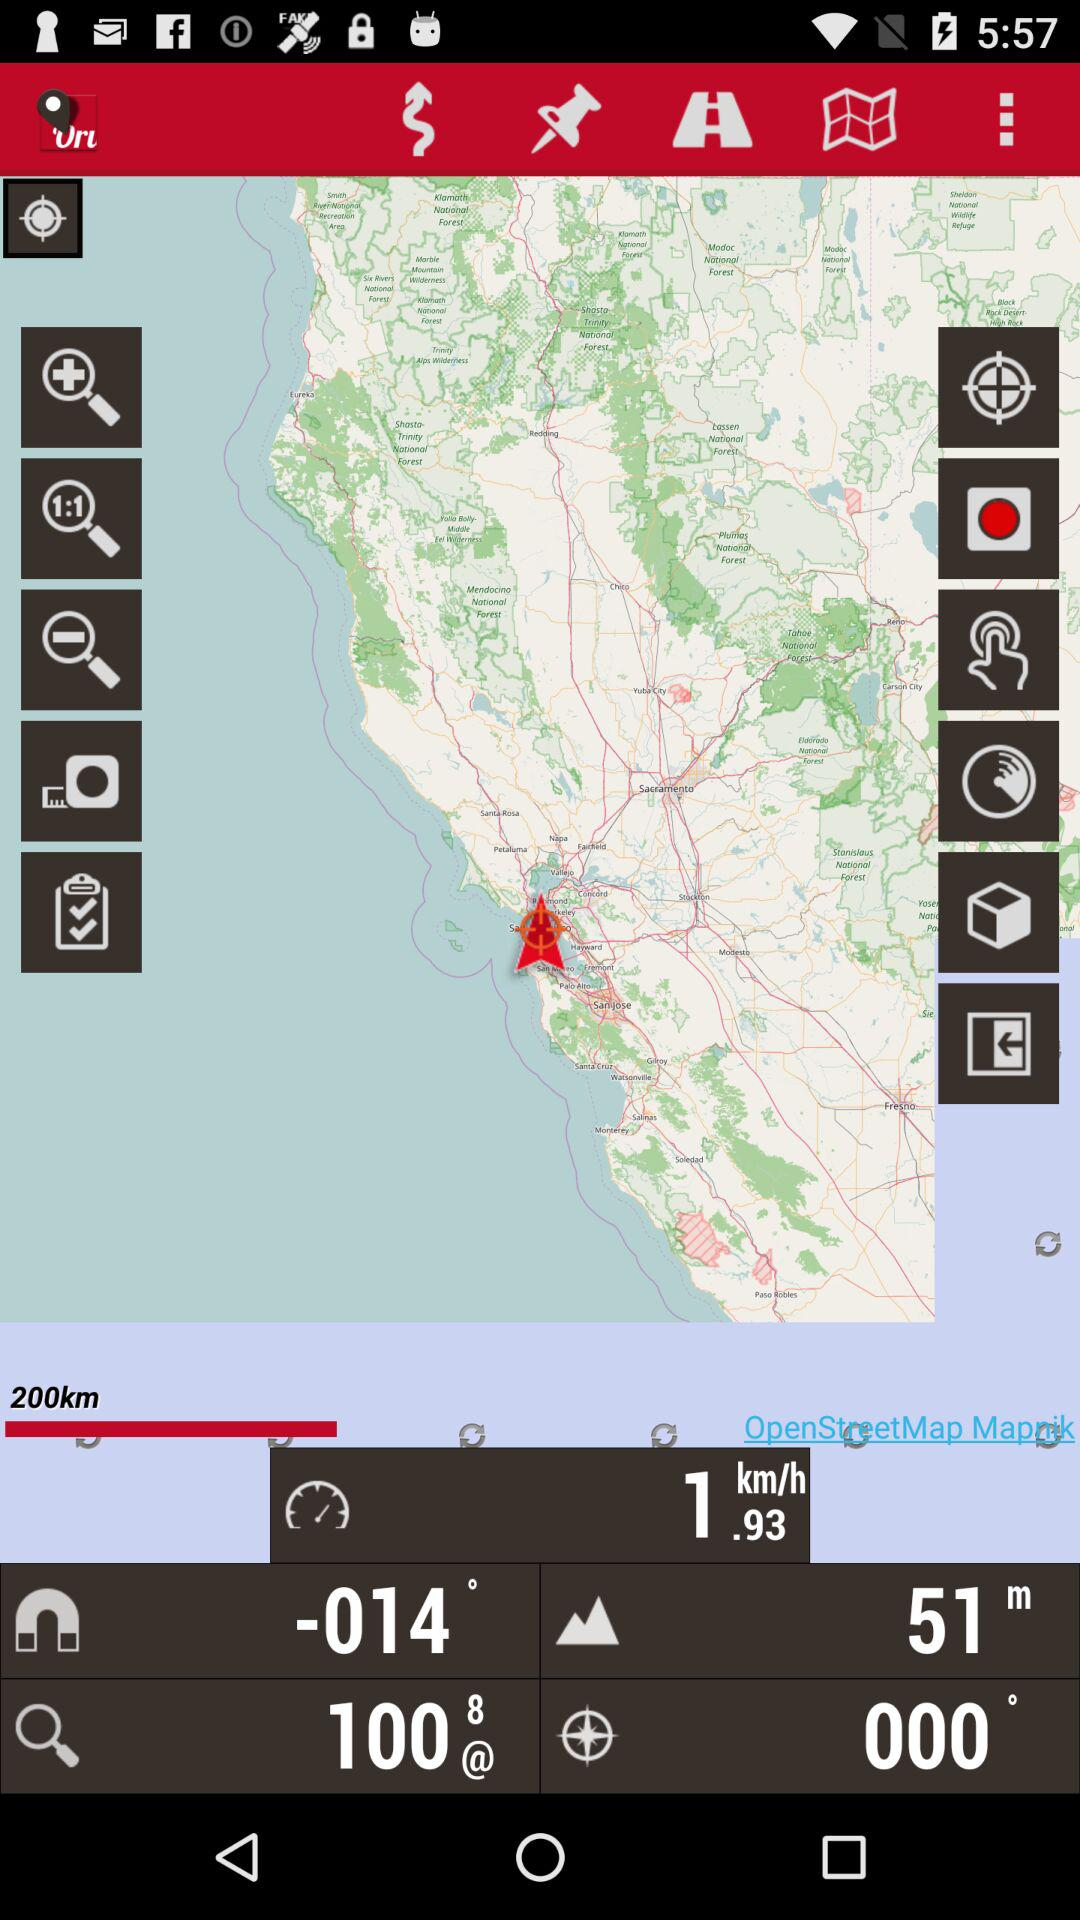How much is zoom?
When the provided information is insufficient, respond with <no answer>. <no answer> 